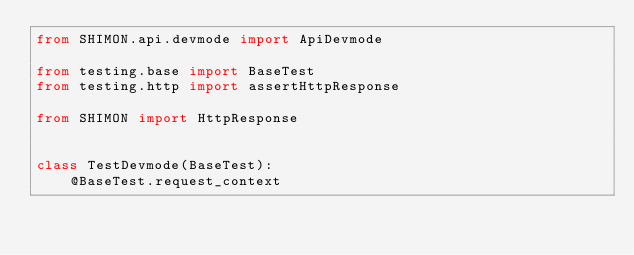<code> <loc_0><loc_0><loc_500><loc_500><_Python_>from SHIMON.api.devmode import ApiDevmode

from testing.base import BaseTest
from testing.http import assertHttpResponse

from SHIMON import HttpResponse


class TestDevmode(BaseTest):
    @BaseTest.request_context</code> 